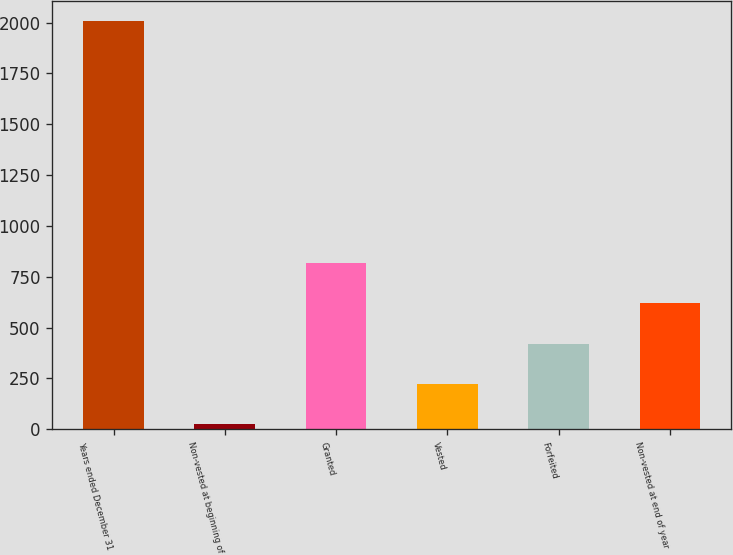Convert chart to OTSL. <chart><loc_0><loc_0><loc_500><loc_500><bar_chart><fcel>Years ended December 31<fcel>Non-vested at beginning of<fcel>Granted<fcel>Vested<fcel>Forfeited<fcel>Non-vested at end of year<nl><fcel>2006<fcel>25<fcel>817.4<fcel>223.1<fcel>421.2<fcel>619.3<nl></chart> 